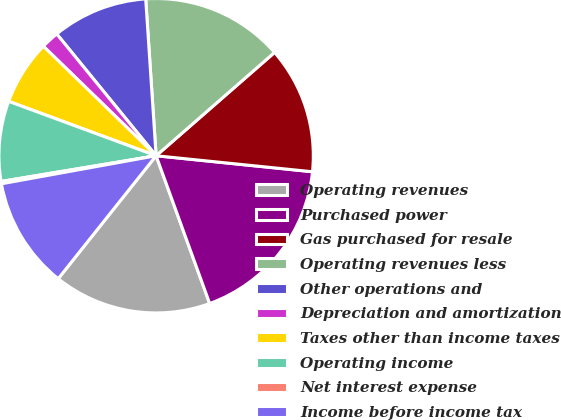Convert chart. <chart><loc_0><loc_0><loc_500><loc_500><pie_chart><fcel>Operating revenues<fcel>Purchased power<fcel>Gas purchased for resale<fcel>Operating revenues less<fcel>Other operations and<fcel>Depreciation and amortization<fcel>Taxes other than income taxes<fcel>Operating income<fcel>Net interest expense<fcel>Income before income tax<nl><fcel>16.24%<fcel>17.84%<fcel>13.04%<fcel>14.64%<fcel>9.84%<fcel>1.84%<fcel>6.64%<fcel>8.24%<fcel>0.24%<fcel>11.44%<nl></chart> 